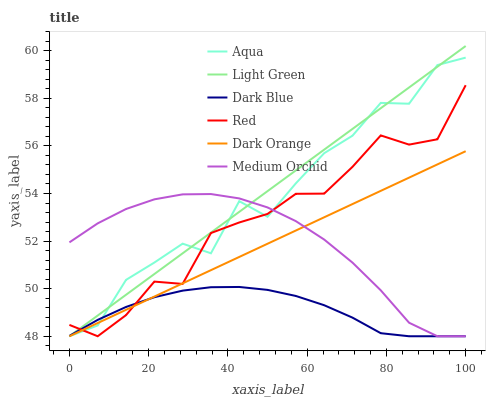Does Dark Blue have the minimum area under the curve?
Answer yes or no. Yes. Does Light Green have the maximum area under the curve?
Answer yes or no. Yes. Does Medium Orchid have the minimum area under the curve?
Answer yes or no. No. Does Medium Orchid have the maximum area under the curve?
Answer yes or no. No. Is Dark Orange the smoothest?
Answer yes or no. Yes. Is Aqua the roughest?
Answer yes or no. Yes. Is Medium Orchid the smoothest?
Answer yes or no. No. Is Medium Orchid the roughest?
Answer yes or no. No. Does Dark Orange have the lowest value?
Answer yes or no. Yes. Does Light Green have the highest value?
Answer yes or no. Yes. Does Medium Orchid have the highest value?
Answer yes or no. No. Does Red intersect Aqua?
Answer yes or no. Yes. Is Red less than Aqua?
Answer yes or no. No. Is Red greater than Aqua?
Answer yes or no. No. 